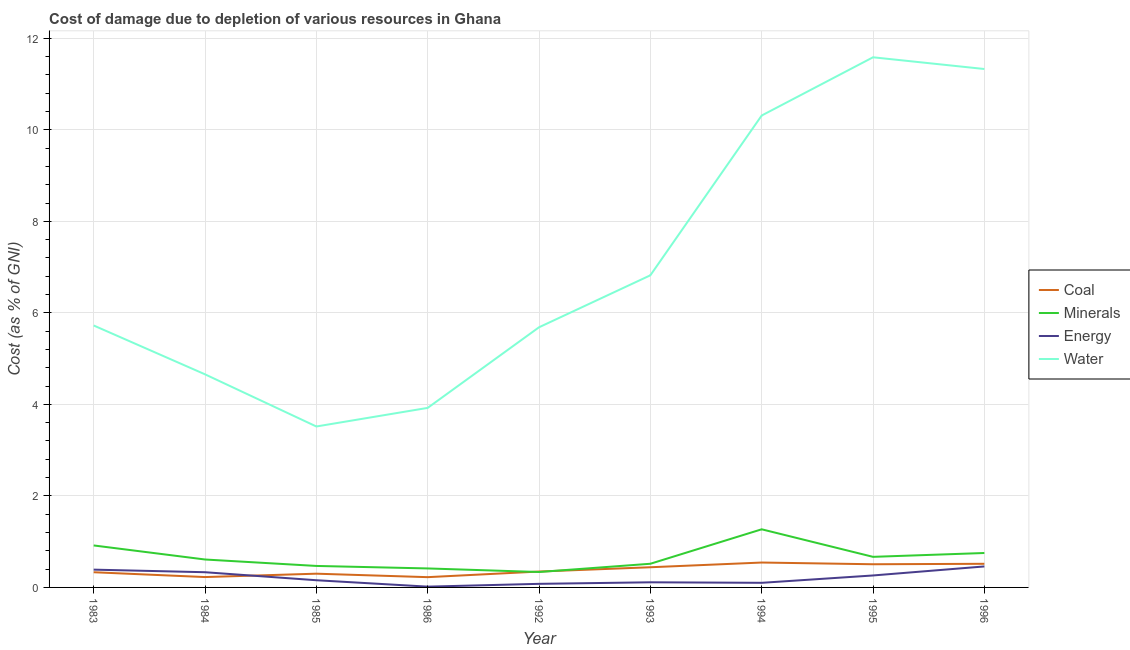Does the line corresponding to cost of damage due to depletion of coal intersect with the line corresponding to cost of damage due to depletion of energy?
Provide a succinct answer. Yes. What is the cost of damage due to depletion of coal in 1995?
Provide a succinct answer. 0.51. Across all years, what is the maximum cost of damage due to depletion of coal?
Keep it short and to the point. 0.54. Across all years, what is the minimum cost of damage due to depletion of energy?
Offer a terse response. 0.02. In which year was the cost of damage due to depletion of water maximum?
Make the answer very short. 1995. In which year was the cost of damage due to depletion of water minimum?
Offer a very short reply. 1985. What is the total cost of damage due to depletion of water in the graph?
Provide a short and direct response. 63.55. What is the difference between the cost of damage due to depletion of coal in 1986 and that in 1996?
Keep it short and to the point. -0.29. What is the difference between the cost of damage due to depletion of energy in 1985 and the cost of damage due to depletion of coal in 1983?
Provide a short and direct response. -0.18. What is the average cost of damage due to depletion of water per year?
Give a very brief answer. 7.06. In the year 1983, what is the difference between the cost of damage due to depletion of water and cost of damage due to depletion of energy?
Your response must be concise. 5.34. In how many years, is the cost of damage due to depletion of water greater than 10.8 %?
Your answer should be very brief. 2. What is the ratio of the cost of damage due to depletion of coal in 1994 to that in 1995?
Ensure brevity in your answer.  1.07. Is the difference between the cost of damage due to depletion of coal in 1992 and 1995 greater than the difference between the cost of damage due to depletion of water in 1992 and 1995?
Make the answer very short. Yes. What is the difference between the highest and the second highest cost of damage due to depletion of minerals?
Keep it short and to the point. 0.35. What is the difference between the highest and the lowest cost of damage due to depletion of coal?
Ensure brevity in your answer.  0.32. Is it the case that in every year, the sum of the cost of damage due to depletion of minerals and cost of damage due to depletion of water is greater than the sum of cost of damage due to depletion of coal and cost of damage due to depletion of energy?
Keep it short and to the point. No. Is it the case that in every year, the sum of the cost of damage due to depletion of coal and cost of damage due to depletion of minerals is greater than the cost of damage due to depletion of energy?
Keep it short and to the point. Yes. Is the cost of damage due to depletion of water strictly less than the cost of damage due to depletion of energy over the years?
Provide a succinct answer. No. What is the difference between two consecutive major ticks on the Y-axis?
Provide a succinct answer. 2. Are the values on the major ticks of Y-axis written in scientific E-notation?
Your response must be concise. No. What is the title of the graph?
Provide a short and direct response. Cost of damage due to depletion of various resources in Ghana . Does "Methodology assessment" appear as one of the legend labels in the graph?
Offer a very short reply. No. What is the label or title of the Y-axis?
Provide a short and direct response. Cost (as % of GNI). What is the Cost (as % of GNI) in Coal in 1983?
Keep it short and to the point. 0.33. What is the Cost (as % of GNI) in Minerals in 1983?
Your answer should be very brief. 0.92. What is the Cost (as % of GNI) in Energy in 1983?
Your answer should be compact. 0.39. What is the Cost (as % of GNI) in Water in 1983?
Your answer should be very brief. 5.72. What is the Cost (as % of GNI) in Coal in 1984?
Provide a succinct answer. 0.23. What is the Cost (as % of GNI) in Minerals in 1984?
Your response must be concise. 0.61. What is the Cost (as % of GNI) in Energy in 1984?
Offer a terse response. 0.33. What is the Cost (as % of GNI) in Water in 1984?
Make the answer very short. 4.66. What is the Cost (as % of GNI) in Coal in 1985?
Keep it short and to the point. 0.3. What is the Cost (as % of GNI) of Minerals in 1985?
Provide a short and direct response. 0.47. What is the Cost (as % of GNI) of Energy in 1985?
Give a very brief answer. 0.16. What is the Cost (as % of GNI) of Water in 1985?
Your answer should be compact. 3.52. What is the Cost (as % of GNI) of Coal in 1986?
Provide a succinct answer. 0.22. What is the Cost (as % of GNI) of Minerals in 1986?
Offer a very short reply. 0.41. What is the Cost (as % of GNI) of Energy in 1986?
Your answer should be very brief. 0.02. What is the Cost (as % of GNI) of Water in 1986?
Offer a very short reply. 3.92. What is the Cost (as % of GNI) of Coal in 1992?
Offer a very short reply. 0.35. What is the Cost (as % of GNI) in Minerals in 1992?
Provide a short and direct response. 0.34. What is the Cost (as % of GNI) of Energy in 1992?
Make the answer very short. 0.08. What is the Cost (as % of GNI) of Water in 1992?
Offer a very short reply. 5.68. What is the Cost (as % of GNI) of Coal in 1993?
Make the answer very short. 0.44. What is the Cost (as % of GNI) in Minerals in 1993?
Ensure brevity in your answer.  0.52. What is the Cost (as % of GNI) in Energy in 1993?
Keep it short and to the point. 0.11. What is the Cost (as % of GNI) in Water in 1993?
Your response must be concise. 6.82. What is the Cost (as % of GNI) in Coal in 1994?
Offer a very short reply. 0.54. What is the Cost (as % of GNI) of Minerals in 1994?
Provide a succinct answer. 1.27. What is the Cost (as % of GNI) in Energy in 1994?
Your answer should be compact. 0.1. What is the Cost (as % of GNI) of Water in 1994?
Offer a very short reply. 10.31. What is the Cost (as % of GNI) in Coal in 1995?
Your answer should be compact. 0.51. What is the Cost (as % of GNI) in Minerals in 1995?
Offer a terse response. 0.67. What is the Cost (as % of GNI) of Energy in 1995?
Your answer should be very brief. 0.26. What is the Cost (as % of GNI) of Water in 1995?
Offer a very short reply. 11.58. What is the Cost (as % of GNI) of Coal in 1996?
Provide a short and direct response. 0.52. What is the Cost (as % of GNI) of Minerals in 1996?
Provide a succinct answer. 0.75. What is the Cost (as % of GNI) in Energy in 1996?
Make the answer very short. 0.46. What is the Cost (as % of GNI) of Water in 1996?
Your response must be concise. 11.33. Across all years, what is the maximum Cost (as % of GNI) in Coal?
Your answer should be compact. 0.54. Across all years, what is the maximum Cost (as % of GNI) of Minerals?
Keep it short and to the point. 1.27. Across all years, what is the maximum Cost (as % of GNI) in Energy?
Provide a succinct answer. 0.46. Across all years, what is the maximum Cost (as % of GNI) in Water?
Provide a short and direct response. 11.58. Across all years, what is the minimum Cost (as % of GNI) of Coal?
Your answer should be compact. 0.22. Across all years, what is the minimum Cost (as % of GNI) of Minerals?
Make the answer very short. 0.34. Across all years, what is the minimum Cost (as % of GNI) in Energy?
Provide a short and direct response. 0.02. Across all years, what is the minimum Cost (as % of GNI) of Water?
Give a very brief answer. 3.52. What is the total Cost (as % of GNI) in Coal in the graph?
Your answer should be compact. 3.44. What is the total Cost (as % of GNI) of Minerals in the graph?
Give a very brief answer. 5.96. What is the total Cost (as % of GNI) of Energy in the graph?
Your answer should be very brief. 1.91. What is the total Cost (as % of GNI) in Water in the graph?
Offer a terse response. 63.55. What is the difference between the Cost (as % of GNI) of Coal in 1983 and that in 1984?
Offer a terse response. 0.11. What is the difference between the Cost (as % of GNI) in Minerals in 1983 and that in 1984?
Offer a terse response. 0.31. What is the difference between the Cost (as % of GNI) in Energy in 1983 and that in 1984?
Offer a terse response. 0.06. What is the difference between the Cost (as % of GNI) in Water in 1983 and that in 1984?
Give a very brief answer. 1.07. What is the difference between the Cost (as % of GNI) in Coal in 1983 and that in 1985?
Your answer should be very brief. 0.03. What is the difference between the Cost (as % of GNI) in Minerals in 1983 and that in 1985?
Provide a short and direct response. 0.45. What is the difference between the Cost (as % of GNI) in Energy in 1983 and that in 1985?
Provide a short and direct response. 0.23. What is the difference between the Cost (as % of GNI) in Water in 1983 and that in 1985?
Ensure brevity in your answer.  2.21. What is the difference between the Cost (as % of GNI) in Coal in 1983 and that in 1986?
Your response must be concise. 0.11. What is the difference between the Cost (as % of GNI) of Minerals in 1983 and that in 1986?
Keep it short and to the point. 0.5. What is the difference between the Cost (as % of GNI) of Energy in 1983 and that in 1986?
Your answer should be compact. 0.37. What is the difference between the Cost (as % of GNI) in Water in 1983 and that in 1986?
Provide a short and direct response. 1.8. What is the difference between the Cost (as % of GNI) of Coal in 1983 and that in 1992?
Your answer should be compact. -0.01. What is the difference between the Cost (as % of GNI) in Minerals in 1983 and that in 1992?
Provide a succinct answer. 0.58. What is the difference between the Cost (as % of GNI) in Energy in 1983 and that in 1992?
Offer a very short reply. 0.31. What is the difference between the Cost (as % of GNI) in Water in 1983 and that in 1992?
Keep it short and to the point. 0.04. What is the difference between the Cost (as % of GNI) of Coal in 1983 and that in 1993?
Give a very brief answer. -0.11. What is the difference between the Cost (as % of GNI) of Minerals in 1983 and that in 1993?
Give a very brief answer. 0.4. What is the difference between the Cost (as % of GNI) in Energy in 1983 and that in 1993?
Offer a terse response. 0.28. What is the difference between the Cost (as % of GNI) of Water in 1983 and that in 1993?
Offer a terse response. -1.1. What is the difference between the Cost (as % of GNI) of Coal in 1983 and that in 1994?
Your answer should be very brief. -0.21. What is the difference between the Cost (as % of GNI) in Minerals in 1983 and that in 1994?
Offer a terse response. -0.35. What is the difference between the Cost (as % of GNI) in Energy in 1983 and that in 1994?
Offer a terse response. 0.29. What is the difference between the Cost (as % of GNI) in Water in 1983 and that in 1994?
Ensure brevity in your answer.  -4.59. What is the difference between the Cost (as % of GNI) of Coal in 1983 and that in 1995?
Offer a very short reply. -0.17. What is the difference between the Cost (as % of GNI) of Minerals in 1983 and that in 1995?
Offer a very short reply. 0.25. What is the difference between the Cost (as % of GNI) of Energy in 1983 and that in 1995?
Make the answer very short. 0.13. What is the difference between the Cost (as % of GNI) of Water in 1983 and that in 1995?
Give a very brief answer. -5.86. What is the difference between the Cost (as % of GNI) in Coal in 1983 and that in 1996?
Make the answer very short. -0.18. What is the difference between the Cost (as % of GNI) of Minerals in 1983 and that in 1996?
Give a very brief answer. 0.17. What is the difference between the Cost (as % of GNI) of Energy in 1983 and that in 1996?
Offer a terse response. -0.07. What is the difference between the Cost (as % of GNI) of Water in 1983 and that in 1996?
Provide a short and direct response. -5.6. What is the difference between the Cost (as % of GNI) in Coal in 1984 and that in 1985?
Give a very brief answer. -0.07. What is the difference between the Cost (as % of GNI) in Minerals in 1984 and that in 1985?
Keep it short and to the point. 0.14. What is the difference between the Cost (as % of GNI) of Energy in 1984 and that in 1985?
Make the answer very short. 0.18. What is the difference between the Cost (as % of GNI) of Water in 1984 and that in 1985?
Make the answer very short. 1.14. What is the difference between the Cost (as % of GNI) of Coal in 1984 and that in 1986?
Your answer should be compact. 0. What is the difference between the Cost (as % of GNI) of Minerals in 1984 and that in 1986?
Provide a succinct answer. 0.2. What is the difference between the Cost (as % of GNI) of Energy in 1984 and that in 1986?
Your answer should be very brief. 0.32. What is the difference between the Cost (as % of GNI) of Water in 1984 and that in 1986?
Give a very brief answer. 0.73. What is the difference between the Cost (as % of GNI) of Coal in 1984 and that in 1992?
Offer a terse response. -0.12. What is the difference between the Cost (as % of GNI) in Minerals in 1984 and that in 1992?
Make the answer very short. 0.27. What is the difference between the Cost (as % of GNI) of Energy in 1984 and that in 1992?
Your answer should be very brief. 0.25. What is the difference between the Cost (as % of GNI) of Water in 1984 and that in 1992?
Your answer should be very brief. -1.03. What is the difference between the Cost (as % of GNI) of Coal in 1984 and that in 1993?
Your response must be concise. -0.21. What is the difference between the Cost (as % of GNI) in Minerals in 1984 and that in 1993?
Ensure brevity in your answer.  0.09. What is the difference between the Cost (as % of GNI) of Energy in 1984 and that in 1993?
Provide a succinct answer. 0.22. What is the difference between the Cost (as % of GNI) of Water in 1984 and that in 1993?
Provide a short and direct response. -2.16. What is the difference between the Cost (as % of GNI) in Coal in 1984 and that in 1994?
Offer a terse response. -0.32. What is the difference between the Cost (as % of GNI) in Minerals in 1984 and that in 1994?
Your answer should be very brief. -0.66. What is the difference between the Cost (as % of GNI) in Energy in 1984 and that in 1994?
Offer a very short reply. 0.23. What is the difference between the Cost (as % of GNI) of Water in 1984 and that in 1994?
Offer a terse response. -5.66. What is the difference between the Cost (as % of GNI) in Coal in 1984 and that in 1995?
Your answer should be very brief. -0.28. What is the difference between the Cost (as % of GNI) in Minerals in 1984 and that in 1995?
Keep it short and to the point. -0.06. What is the difference between the Cost (as % of GNI) in Energy in 1984 and that in 1995?
Offer a terse response. 0.07. What is the difference between the Cost (as % of GNI) of Water in 1984 and that in 1995?
Your response must be concise. -6.93. What is the difference between the Cost (as % of GNI) of Coal in 1984 and that in 1996?
Give a very brief answer. -0.29. What is the difference between the Cost (as % of GNI) of Minerals in 1984 and that in 1996?
Offer a terse response. -0.14. What is the difference between the Cost (as % of GNI) of Energy in 1984 and that in 1996?
Offer a very short reply. -0.13. What is the difference between the Cost (as % of GNI) in Water in 1984 and that in 1996?
Provide a short and direct response. -6.67. What is the difference between the Cost (as % of GNI) in Coal in 1985 and that in 1986?
Ensure brevity in your answer.  0.08. What is the difference between the Cost (as % of GNI) of Minerals in 1985 and that in 1986?
Your response must be concise. 0.05. What is the difference between the Cost (as % of GNI) of Energy in 1985 and that in 1986?
Give a very brief answer. 0.14. What is the difference between the Cost (as % of GNI) in Water in 1985 and that in 1986?
Provide a short and direct response. -0.41. What is the difference between the Cost (as % of GNI) in Coal in 1985 and that in 1992?
Give a very brief answer. -0.05. What is the difference between the Cost (as % of GNI) in Minerals in 1985 and that in 1992?
Ensure brevity in your answer.  0.13. What is the difference between the Cost (as % of GNI) in Energy in 1985 and that in 1992?
Provide a succinct answer. 0.08. What is the difference between the Cost (as % of GNI) in Water in 1985 and that in 1992?
Offer a terse response. -2.17. What is the difference between the Cost (as % of GNI) in Coal in 1985 and that in 1993?
Give a very brief answer. -0.14. What is the difference between the Cost (as % of GNI) in Minerals in 1985 and that in 1993?
Give a very brief answer. -0.05. What is the difference between the Cost (as % of GNI) in Energy in 1985 and that in 1993?
Your response must be concise. 0.05. What is the difference between the Cost (as % of GNI) of Water in 1985 and that in 1993?
Offer a terse response. -3.3. What is the difference between the Cost (as % of GNI) in Coal in 1985 and that in 1994?
Make the answer very short. -0.24. What is the difference between the Cost (as % of GNI) in Minerals in 1985 and that in 1994?
Your answer should be very brief. -0.8. What is the difference between the Cost (as % of GNI) of Energy in 1985 and that in 1994?
Offer a very short reply. 0.06. What is the difference between the Cost (as % of GNI) in Water in 1985 and that in 1994?
Offer a terse response. -6.8. What is the difference between the Cost (as % of GNI) in Coal in 1985 and that in 1995?
Keep it short and to the point. -0.21. What is the difference between the Cost (as % of GNI) in Minerals in 1985 and that in 1995?
Ensure brevity in your answer.  -0.2. What is the difference between the Cost (as % of GNI) in Energy in 1985 and that in 1995?
Make the answer very short. -0.1. What is the difference between the Cost (as % of GNI) in Water in 1985 and that in 1995?
Keep it short and to the point. -8.07. What is the difference between the Cost (as % of GNI) in Coal in 1985 and that in 1996?
Give a very brief answer. -0.22. What is the difference between the Cost (as % of GNI) of Minerals in 1985 and that in 1996?
Your answer should be very brief. -0.28. What is the difference between the Cost (as % of GNI) in Energy in 1985 and that in 1996?
Ensure brevity in your answer.  -0.3. What is the difference between the Cost (as % of GNI) of Water in 1985 and that in 1996?
Ensure brevity in your answer.  -7.81. What is the difference between the Cost (as % of GNI) of Coal in 1986 and that in 1992?
Offer a terse response. -0.12. What is the difference between the Cost (as % of GNI) in Minerals in 1986 and that in 1992?
Provide a succinct answer. 0.08. What is the difference between the Cost (as % of GNI) of Energy in 1986 and that in 1992?
Give a very brief answer. -0.06. What is the difference between the Cost (as % of GNI) in Water in 1986 and that in 1992?
Offer a very short reply. -1.76. What is the difference between the Cost (as % of GNI) of Coal in 1986 and that in 1993?
Your answer should be compact. -0.22. What is the difference between the Cost (as % of GNI) in Minerals in 1986 and that in 1993?
Provide a succinct answer. -0.1. What is the difference between the Cost (as % of GNI) of Energy in 1986 and that in 1993?
Keep it short and to the point. -0.09. What is the difference between the Cost (as % of GNI) of Water in 1986 and that in 1993?
Offer a very short reply. -2.9. What is the difference between the Cost (as % of GNI) in Coal in 1986 and that in 1994?
Your response must be concise. -0.32. What is the difference between the Cost (as % of GNI) in Minerals in 1986 and that in 1994?
Your response must be concise. -0.86. What is the difference between the Cost (as % of GNI) in Energy in 1986 and that in 1994?
Your answer should be compact. -0.08. What is the difference between the Cost (as % of GNI) of Water in 1986 and that in 1994?
Offer a very short reply. -6.39. What is the difference between the Cost (as % of GNI) of Coal in 1986 and that in 1995?
Give a very brief answer. -0.28. What is the difference between the Cost (as % of GNI) in Minerals in 1986 and that in 1995?
Your response must be concise. -0.25. What is the difference between the Cost (as % of GNI) in Energy in 1986 and that in 1995?
Make the answer very short. -0.24. What is the difference between the Cost (as % of GNI) of Water in 1986 and that in 1995?
Provide a short and direct response. -7.66. What is the difference between the Cost (as % of GNI) in Coal in 1986 and that in 1996?
Provide a short and direct response. -0.29. What is the difference between the Cost (as % of GNI) of Minerals in 1986 and that in 1996?
Your response must be concise. -0.34. What is the difference between the Cost (as % of GNI) of Energy in 1986 and that in 1996?
Offer a very short reply. -0.44. What is the difference between the Cost (as % of GNI) of Water in 1986 and that in 1996?
Your answer should be very brief. -7.41. What is the difference between the Cost (as % of GNI) of Coal in 1992 and that in 1993?
Provide a short and direct response. -0.09. What is the difference between the Cost (as % of GNI) of Minerals in 1992 and that in 1993?
Provide a succinct answer. -0.18. What is the difference between the Cost (as % of GNI) of Energy in 1992 and that in 1993?
Your answer should be compact. -0.03. What is the difference between the Cost (as % of GNI) in Water in 1992 and that in 1993?
Provide a short and direct response. -1.14. What is the difference between the Cost (as % of GNI) in Coal in 1992 and that in 1994?
Ensure brevity in your answer.  -0.2. What is the difference between the Cost (as % of GNI) in Minerals in 1992 and that in 1994?
Your answer should be very brief. -0.93. What is the difference between the Cost (as % of GNI) in Energy in 1992 and that in 1994?
Provide a short and direct response. -0.02. What is the difference between the Cost (as % of GNI) of Water in 1992 and that in 1994?
Offer a terse response. -4.63. What is the difference between the Cost (as % of GNI) of Coal in 1992 and that in 1995?
Keep it short and to the point. -0.16. What is the difference between the Cost (as % of GNI) of Minerals in 1992 and that in 1995?
Provide a succinct answer. -0.33. What is the difference between the Cost (as % of GNI) of Energy in 1992 and that in 1995?
Your answer should be compact. -0.18. What is the difference between the Cost (as % of GNI) in Water in 1992 and that in 1995?
Offer a very short reply. -5.9. What is the difference between the Cost (as % of GNI) of Coal in 1992 and that in 1996?
Offer a very short reply. -0.17. What is the difference between the Cost (as % of GNI) of Minerals in 1992 and that in 1996?
Provide a succinct answer. -0.42. What is the difference between the Cost (as % of GNI) of Energy in 1992 and that in 1996?
Your answer should be very brief. -0.38. What is the difference between the Cost (as % of GNI) of Water in 1992 and that in 1996?
Offer a terse response. -5.64. What is the difference between the Cost (as % of GNI) of Coal in 1993 and that in 1994?
Your answer should be compact. -0.1. What is the difference between the Cost (as % of GNI) of Minerals in 1993 and that in 1994?
Your response must be concise. -0.75. What is the difference between the Cost (as % of GNI) of Energy in 1993 and that in 1994?
Your answer should be very brief. 0.01. What is the difference between the Cost (as % of GNI) of Water in 1993 and that in 1994?
Your response must be concise. -3.49. What is the difference between the Cost (as % of GNI) of Coal in 1993 and that in 1995?
Keep it short and to the point. -0.07. What is the difference between the Cost (as % of GNI) in Minerals in 1993 and that in 1995?
Give a very brief answer. -0.15. What is the difference between the Cost (as % of GNI) in Energy in 1993 and that in 1995?
Keep it short and to the point. -0.15. What is the difference between the Cost (as % of GNI) in Water in 1993 and that in 1995?
Keep it short and to the point. -4.76. What is the difference between the Cost (as % of GNI) of Coal in 1993 and that in 1996?
Your answer should be compact. -0.08. What is the difference between the Cost (as % of GNI) in Minerals in 1993 and that in 1996?
Keep it short and to the point. -0.24. What is the difference between the Cost (as % of GNI) of Energy in 1993 and that in 1996?
Your answer should be compact. -0.35. What is the difference between the Cost (as % of GNI) of Water in 1993 and that in 1996?
Provide a succinct answer. -4.51. What is the difference between the Cost (as % of GNI) of Coal in 1994 and that in 1995?
Offer a very short reply. 0.04. What is the difference between the Cost (as % of GNI) in Minerals in 1994 and that in 1995?
Provide a succinct answer. 0.6. What is the difference between the Cost (as % of GNI) in Energy in 1994 and that in 1995?
Provide a short and direct response. -0.16. What is the difference between the Cost (as % of GNI) of Water in 1994 and that in 1995?
Provide a short and direct response. -1.27. What is the difference between the Cost (as % of GNI) of Coal in 1994 and that in 1996?
Offer a terse response. 0.03. What is the difference between the Cost (as % of GNI) in Minerals in 1994 and that in 1996?
Your response must be concise. 0.52. What is the difference between the Cost (as % of GNI) in Energy in 1994 and that in 1996?
Make the answer very short. -0.36. What is the difference between the Cost (as % of GNI) in Water in 1994 and that in 1996?
Your answer should be compact. -1.02. What is the difference between the Cost (as % of GNI) of Coal in 1995 and that in 1996?
Your answer should be compact. -0.01. What is the difference between the Cost (as % of GNI) of Minerals in 1995 and that in 1996?
Your response must be concise. -0.08. What is the difference between the Cost (as % of GNI) in Energy in 1995 and that in 1996?
Offer a terse response. -0.2. What is the difference between the Cost (as % of GNI) of Water in 1995 and that in 1996?
Your response must be concise. 0.26. What is the difference between the Cost (as % of GNI) of Coal in 1983 and the Cost (as % of GNI) of Minerals in 1984?
Ensure brevity in your answer.  -0.28. What is the difference between the Cost (as % of GNI) of Coal in 1983 and the Cost (as % of GNI) of Energy in 1984?
Offer a very short reply. -0. What is the difference between the Cost (as % of GNI) in Coal in 1983 and the Cost (as % of GNI) in Water in 1984?
Your answer should be very brief. -4.32. What is the difference between the Cost (as % of GNI) of Minerals in 1983 and the Cost (as % of GNI) of Energy in 1984?
Provide a succinct answer. 0.58. What is the difference between the Cost (as % of GNI) of Minerals in 1983 and the Cost (as % of GNI) of Water in 1984?
Make the answer very short. -3.74. What is the difference between the Cost (as % of GNI) of Energy in 1983 and the Cost (as % of GNI) of Water in 1984?
Provide a short and direct response. -4.27. What is the difference between the Cost (as % of GNI) of Coal in 1983 and the Cost (as % of GNI) of Minerals in 1985?
Your answer should be very brief. -0.14. What is the difference between the Cost (as % of GNI) of Coal in 1983 and the Cost (as % of GNI) of Energy in 1985?
Provide a short and direct response. 0.17. What is the difference between the Cost (as % of GNI) of Coal in 1983 and the Cost (as % of GNI) of Water in 1985?
Your answer should be compact. -3.18. What is the difference between the Cost (as % of GNI) of Minerals in 1983 and the Cost (as % of GNI) of Energy in 1985?
Give a very brief answer. 0.76. What is the difference between the Cost (as % of GNI) of Minerals in 1983 and the Cost (as % of GNI) of Water in 1985?
Your answer should be compact. -2.6. What is the difference between the Cost (as % of GNI) in Energy in 1983 and the Cost (as % of GNI) in Water in 1985?
Provide a succinct answer. -3.13. What is the difference between the Cost (as % of GNI) in Coal in 1983 and the Cost (as % of GNI) in Minerals in 1986?
Your answer should be compact. -0.08. What is the difference between the Cost (as % of GNI) in Coal in 1983 and the Cost (as % of GNI) in Energy in 1986?
Make the answer very short. 0.31. What is the difference between the Cost (as % of GNI) of Coal in 1983 and the Cost (as % of GNI) of Water in 1986?
Keep it short and to the point. -3.59. What is the difference between the Cost (as % of GNI) in Minerals in 1983 and the Cost (as % of GNI) in Energy in 1986?
Provide a short and direct response. 0.9. What is the difference between the Cost (as % of GNI) in Minerals in 1983 and the Cost (as % of GNI) in Water in 1986?
Your answer should be compact. -3.01. What is the difference between the Cost (as % of GNI) of Energy in 1983 and the Cost (as % of GNI) of Water in 1986?
Your answer should be very brief. -3.53. What is the difference between the Cost (as % of GNI) in Coal in 1983 and the Cost (as % of GNI) in Minerals in 1992?
Ensure brevity in your answer.  -0.01. What is the difference between the Cost (as % of GNI) in Coal in 1983 and the Cost (as % of GNI) in Energy in 1992?
Keep it short and to the point. 0.25. What is the difference between the Cost (as % of GNI) in Coal in 1983 and the Cost (as % of GNI) in Water in 1992?
Give a very brief answer. -5.35. What is the difference between the Cost (as % of GNI) in Minerals in 1983 and the Cost (as % of GNI) in Energy in 1992?
Your response must be concise. 0.84. What is the difference between the Cost (as % of GNI) in Minerals in 1983 and the Cost (as % of GNI) in Water in 1992?
Provide a short and direct response. -4.77. What is the difference between the Cost (as % of GNI) of Energy in 1983 and the Cost (as % of GNI) of Water in 1992?
Provide a short and direct response. -5.3. What is the difference between the Cost (as % of GNI) in Coal in 1983 and the Cost (as % of GNI) in Minerals in 1993?
Provide a succinct answer. -0.19. What is the difference between the Cost (as % of GNI) of Coal in 1983 and the Cost (as % of GNI) of Energy in 1993?
Ensure brevity in your answer.  0.22. What is the difference between the Cost (as % of GNI) of Coal in 1983 and the Cost (as % of GNI) of Water in 1993?
Provide a short and direct response. -6.49. What is the difference between the Cost (as % of GNI) in Minerals in 1983 and the Cost (as % of GNI) in Energy in 1993?
Ensure brevity in your answer.  0.81. What is the difference between the Cost (as % of GNI) of Minerals in 1983 and the Cost (as % of GNI) of Water in 1993?
Offer a very short reply. -5.9. What is the difference between the Cost (as % of GNI) of Energy in 1983 and the Cost (as % of GNI) of Water in 1993?
Give a very brief answer. -6.43. What is the difference between the Cost (as % of GNI) in Coal in 1983 and the Cost (as % of GNI) in Minerals in 1994?
Ensure brevity in your answer.  -0.94. What is the difference between the Cost (as % of GNI) in Coal in 1983 and the Cost (as % of GNI) in Energy in 1994?
Give a very brief answer. 0.23. What is the difference between the Cost (as % of GNI) in Coal in 1983 and the Cost (as % of GNI) in Water in 1994?
Give a very brief answer. -9.98. What is the difference between the Cost (as % of GNI) in Minerals in 1983 and the Cost (as % of GNI) in Energy in 1994?
Provide a succinct answer. 0.82. What is the difference between the Cost (as % of GNI) in Minerals in 1983 and the Cost (as % of GNI) in Water in 1994?
Make the answer very short. -9.39. What is the difference between the Cost (as % of GNI) in Energy in 1983 and the Cost (as % of GNI) in Water in 1994?
Provide a short and direct response. -9.92. What is the difference between the Cost (as % of GNI) in Coal in 1983 and the Cost (as % of GNI) in Minerals in 1995?
Make the answer very short. -0.34. What is the difference between the Cost (as % of GNI) in Coal in 1983 and the Cost (as % of GNI) in Energy in 1995?
Offer a very short reply. 0.07. What is the difference between the Cost (as % of GNI) of Coal in 1983 and the Cost (as % of GNI) of Water in 1995?
Provide a short and direct response. -11.25. What is the difference between the Cost (as % of GNI) of Minerals in 1983 and the Cost (as % of GNI) of Energy in 1995?
Give a very brief answer. 0.66. What is the difference between the Cost (as % of GNI) of Minerals in 1983 and the Cost (as % of GNI) of Water in 1995?
Offer a very short reply. -10.67. What is the difference between the Cost (as % of GNI) of Energy in 1983 and the Cost (as % of GNI) of Water in 1995?
Make the answer very short. -11.2. What is the difference between the Cost (as % of GNI) in Coal in 1983 and the Cost (as % of GNI) in Minerals in 1996?
Keep it short and to the point. -0.42. What is the difference between the Cost (as % of GNI) in Coal in 1983 and the Cost (as % of GNI) in Energy in 1996?
Give a very brief answer. -0.13. What is the difference between the Cost (as % of GNI) in Coal in 1983 and the Cost (as % of GNI) in Water in 1996?
Make the answer very short. -11. What is the difference between the Cost (as % of GNI) of Minerals in 1983 and the Cost (as % of GNI) of Energy in 1996?
Your answer should be compact. 0.46. What is the difference between the Cost (as % of GNI) of Minerals in 1983 and the Cost (as % of GNI) of Water in 1996?
Keep it short and to the point. -10.41. What is the difference between the Cost (as % of GNI) of Energy in 1983 and the Cost (as % of GNI) of Water in 1996?
Your answer should be compact. -10.94. What is the difference between the Cost (as % of GNI) of Coal in 1984 and the Cost (as % of GNI) of Minerals in 1985?
Make the answer very short. -0.24. What is the difference between the Cost (as % of GNI) in Coal in 1984 and the Cost (as % of GNI) in Energy in 1985?
Give a very brief answer. 0.07. What is the difference between the Cost (as % of GNI) of Coal in 1984 and the Cost (as % of GNI) of Water in 1985?
Your response must be concise. -3.29. What is the difference between the Cost (as % of GNI) of Minerals in 1984 and the Cost (as % of GNI) of Energy in 1985?
Your response must be concise. 0.45. What is the difference between the Cost (as % of GNI) of Minerals in 1984 and the Cost (as % of GNI) of Water in 1985?
Make the answer very short. -2.91. What is the difference between the Cost (as % of GNI) of Energy in 1984 and the Cost (as % of GNI) of Water in 1985?
Provide a succinct answer. -3.18. What is the difference between the Cost (as % of GNI) of Coal in 1984 and the Cost (as % of GNI) of Minerals in 1986?
Your answer should be very brief. -0.19. What is the difference between the Cost (as % of GNI) of Coal in 1984 and the Cost (as % of GNI) of Energy in 1986?
Your response must be concise. 0.21. What is the difference between the Cost (as % of GNI) in Coal in 1984 and the Cost (as % of GNI) in Water in 1986?
Offer a terse response. -3.7. What is the difference between the Cost (as % of GNI) in Minerals in 1984 and the Cost (as % of GNI) in Energy in 1986?
Your answer should be compact. 0.59. What is the difference between the Cost (as % of GNI) in Minerals in 1984 and the Cost (as % of GNI) in Water in 1986?
Keep it short and to the point. -3.31. What is the difference between the Cost (as % of GNI) in Energy in 1984 and the Cost (as % of GNI) in Water in 1986?
Your answer should be very brief. -3.59. What is the difference between the Cost (as % of GNI) of Coal in 1984 and the Cost (as % of GNI) of Minerals in 1992?
Ensure brevity in your answer.  -0.11. What is the difference between the Cost (as % of GNI) of Coal in 1984 and the Cost (as % of GNI) of Energy in 1992?
Give a very brief answer. 0.15. What is the difference between the Cost (as % of GNI) of Coal in 1984 and the Cost (as % of GNI) of Water in 1992?
Keep it short and to the point. -5.46. What is the difference between the Cost (as % of GNI) of Minerals in 1984 and the Cost (as % of GNI) of Energy in 1992?
Give a very brief answer. 0.53. What is the difference between the Cost (as % of GNI) of Minerals in 1984 and the Cost (as % of GNI) of Water in 1992?
Give a very brief answer. -5.07. What is the difference between the Cost (as % of GNI) in Energy in 1984 and the Cost (as % of GNI) in Water in 1992?
Your answer should be very brief. -5.35. What is the difference between the Cost (as % of GNI) in Coal in 1984 and the Cost (as % of GNI) in Minerals in 1993?
Your answer should be very brief. -0.29. What is the difference between the Cost (as % of GNI) of Coal in 1984 and the Cost (as % of GNI) of Energy in 1993?
Provide a short and direct response. 0.11. What is the difference between the Cost (as % of GNI) of Coal in 1984 and the Cost (as % of GNI) of Water in 1993?
Ensure brevity in your answer.  -6.59. What is the difference between the Cost (as % of GNI) in Minerals in 1984 and the Cost (as % of GNI) in Energy in 1993?
Offer a very short reply. 0.5. What is the difference between the Cost (as % of GNI) of Minerals in 1984 and the Cost (as % of GNI) of Water in 1993?
Provide a short and direct response. -6.21. What is the difference between the Cost (as % of GNI) of Energy in 1984 and the Cost (as % of GNI) of Water in 1993?
Your response must be concise. -6.49. What is the difference between the Cost (as % of GNI) of Coal in 1984 and the Cost (as % of GNI) of Minerals in 1994?
Your response must be concise. -1.04. What is the difference between the Cost (as % of GNI) of Coal in 1984 and the Cost (as % of GNI) of Energy in 1994?
Provide a succinct answer. 0.13. What is the difference between the Cost (as % of GNI) in Coal in 1984 and the Cost (as % of GNI) in Water in 1994?
Offer a very short reply. -10.09. What is the difference between the Cost (as % of GNI) in Minerals in 1984 and the Cost (as % of GNI) in Energy in 1994?
Your answer should be compact. 0.51. What is the difference between the Cost (as % of GNI) of Minerals in 1984 and the Cost (as % of GNI) of Water in 1994?
Give a very brief answer. -9.7. What is the difference between the Cost (as % of GNI) in Energy in 1984 and the Cost (as % of GNI) in Water in 1994?
Keep it short and to the point. -9.98. What is the difference between the Cost (as % of GNI) of Coal in 1984 and the Cost (as % of GNI) of Minerals in 1995?
Your answer should be compact. -0.44. What is the difference between the Cost (as % of GNI) of Coal in 1984 and the Cost (as % of GNI) of Energy in 1995?
Offer a terse response. -0.04. What is the difference between the Cost (as % of GNI) of Coal in 1984 and the Cost (as % of GNI) of Water in 1995?
Give a very brief answer. -11.36. What is the difference between the Cost (as % of GNI) of Minerals in 1984 and the Cost (as % of GNI) of Energy in 1995?
Keep it short and to the point. 0.35. What is the difference between the Cost (as % of GNI) in Minerals in 1984 and the Cost (as % of GNI) in Water in 1995?
Provide a short and direct response. -10.97. What is the difference between the Cost (as % of GNI) of Energy in 1984 and the Cost (as % of GNI) of Water in 1995?
Make the answer very short. -11.25. What is the difference between the Cost (as % of GNI) in Coal in 1984 and the Cost (as % of GNI) in Minerals in 1996?
Provide a succinct answer. -0.53. What is the difference between the Cost (as % of GNI) in Coal in 1984 and the Cost (as % of GNI) in Energy in 1996?
Give a very brief answer. -0.23. What is the difference between the Cost (as % of GNI) of Coal in 1984 and the Cost (as % of GNI) of Water in 1996?
Make the answer very short. -11.1. What is the difference between the Cost (as % of GNI) of Minerals in 1984 and the Cost (as % of GNI) of Energy in 1996?
Provide a short and direct response. 0.15. What is the difference between the Cost (as % of GNI) of Minerals in 1984 and the Cost (as % of GNI) of Water in 1996?
Offer a terse response. -10.72. What is the difference between the Cost (as % of GNI) in Energy in 1984 and the Cost (as % of GNI) in Water in 1996?
Offer a very short reply. -11. What is the difference between the Cost (as % of GNI) of Coal in 1985 and the Cost (as % of GNI) of Minerals in 1986?
Provide a succinct answer. -0.11. What is the difference between the Cost (as % of GNI) in Coal in 1985 and the Cost (as % of GNI) in Energy in 1986?
Provide a succinct answer. 0.28. What is the difference between the Cost (as % of GNI) of Coal in 1985 and the Cost (as % of GNI) of Water in 1986?
Offer a very short reply. -3.62. What is the difference between the Cost (as % of GNI) in Minerals in 1985 and the Cost (as % of GNI) in Energy in 1986?
Offer a terse response. 0.45. What is the difference between the Cost (as % of GNI) of Minerals in 1985 and the Cost (as % of GNI) of Water in 1986?
Offer a very short reply. -3.45. What is the difference between the Cost (as % of GNI) of Energy in 1985 and the Cost (as % of GNI) of Water in 1986?
Make the answer very short. -3.77. What is the difference between the Cost (as % of GNI) of Coal in 1985 and the Cost (as % of GNI) of Minerals in 1992?
Provide a succinct answer. -0.04. What is the difference between the Cost (as % of GNI) of Coal in 1985 and the Cost (as % of GNI) of Energy in 1992?
Your answer should be compact. 0.22. What is the difference between the Cost (as % of GNI) in Coal in 1985 and the Cost (as % of GNI) in Water in 1992?
Provide a short and direct response. -5.38. What is the difference between the Cost (as % of GNI) of Minerals in 1985 and the Cost (as % of GNI) of Energy in 1992?
Offer a very short reply. 0.39. What is the difference between the Cost (as % of GNI) of Minerals in 1985 and the Cost (as % of GNI) of Water in 1992?
Provide a succinct answer. -5.22. What is the difference between the Cost (as % of GNI) in Energy in 1985 and the Cost (as % of GNI) in Water in 1992?
Keep it short and to the point. -5.53. What is the difference between the Cost (as % of GNI) in Coal in 1985 and the Cost (as % of GNI) in Minerals in 1993?
Your response must be concise. -0.22. What is the difference between the Cost (as % of GNI) of Coal in 1985 and the Cost (as % of GNI) of Energy in 1993?
Make the answer very short. 0.19. What is the difference between the Cost (as % of GNI) of Coal in 1985 and the Cost (as % of GNI) of Water in 1993?
Give a very brief answer. -6.52. What is the difference between the Cost (as % of GNI) in Minerals in 1985 and the Cost (as % of GNI) in Energy in 1993?
Keep it short and to the point. 0.36. What is the difference between the Cost (as % of GNI) in Minerals in 1985 and the Cost (as % of GNI) in Water in 1993?
Provide a short and direct response. -6.35. What is the difference between the Cost (as % of GNI) of Energy in 1985 and the Cost (as % of GNI) of Water in 1993?
Provide a succinct answer. -6.66. What is the difference between the Cost (as % of GNI) in Coal in 1985 and the Cost (as % of GNI) in Minerals in 1994?
Ensure brevity in your answer.  -0.97. What is the difference between the Cost (as % of GNI) of Coal in 1985 and the Cost (as % of GNI) of Energy in 1994?
Keep it short and to the point. 0.2. What is the difference between the Cost (as % of GNI) of Coal in 1985 and the Cost (as % of GNI) of Water in 1994?
Give a very brief answer. -10.01. What is the difference between the Cost (as % of GNI) in Minerals in 1985 and the Cost (as % of GNI) in Energy in 1994?
Ensure brevity in your answer.  0.37. What is the difference between the Cost (as % of GNI) of Minerals in 1985 and the Cost (as % of GNI) of Water in 1994?
Provide a succinct answer. -9.84. What is the difference between the Cost (as % of GNI) in Energy in 1985 and the Cost (as % of GNI) in Water in 1994?
Your answer should be very brief. -10.16. What is the difference between the Cost (as % of GNI) of Coal in 1985 and the Cost (as % of GNI) of Minerals in 1995?
Offer a very short reply. -0.37. What is the difference between the Cost (as % of GNI) in Coal in 1985 and the Cost (as % of GNI) in Energy in 1995?
Offer a very short reply. 0.04. What is the difference between the Cost (as % of GNI) in Coal in 1985 and the Cost (as % of GNI) in Water in 1995?
Offer a terse response. -11.28. What is the difference between the Cost (as % of GNI) in Minerals in 1985 and the Cost (as % of GNI) in Energy in 1995?
Provide a succinct answer. 0.21. What is the difference between the Cost (as % of GNI) of Minerals in 1985 and the Cost (as % of GNI) of Water in 1995?
Keep it short and to the point. -11.12. What is the difference between the Cost (as % of GNI) in Energy in 1985 and the Cost (as % of GNI) in Water in 1995?
Give a very brief answer. -11.43. What is the difference between the Cost (as % of GNI) of Coal in 1985 and the Cost (as % of GNI) of Minerals in 1996?
Your answer should be compact. -0.45. What is the difference between the Cost (as % of GNI) of Coal in 1985 and the Cost (as % of GNI) of Energy in 1996?
Provide a short and direct response. -0.16. What is the difference between the Cost (as % of GNI) of Coal in 1985 and the Cost (as % of GNI) of Water in 1996?
Provide a short and direct response. -11.03. What is the difference between the Cost (as % of GNI) in Minerals in 1985 and the Cost (as % of GNI) in Energy in 1996?
Give a very brief answer. 0.01. What is the difference between the Cost (as % of GNI) in Minerals in 1985 and the Cost (as % of GNI) in Water in 1996?
Ensure brevity in your answer.  -10.86. What is the difference between the Cost (as % of GNI) of Energy in 1985 and the Cost (as % of GNI) of Water in 1996?
Ensure brevity in your answer.  -11.17. What is the difference between the Cost (as % of GNI) in Coal in 1986 and the Cost (as % of GNI) in Minerals in 1992?
Give a very brief answer. -0.11. What is the difference between the Cost (as % of GNI) of Coal in 1986 and the Cost (as % of GNI) of Energy in 1992?
Your response must be concise. 0.15. What is the difference between the Cost (as % of GNI) of Coal in 1986 and the Cost (as % of GNI) of Water in 1992?
Make the answer very short. -5.46. What is the difference between the Cost (as % of GNI) of Minerals in 1986 and the Cost (as % of GNI) of Energy in 1992?
Give a very brief answer. 0.34. What is the difference between the Cost (as % of GNI) in Minerals in 1986 and the Cost (as % of GNI) in Water in 1992?
Your answer should be compact. -5.27. What is the difference between the Cost (as % of GNI) of Energy in 1986 and the Cost (as % of GNI) of Water in 1992?
Offer a very short reply. -5.67. What is the difference between the Cost (as % of GNI) in Coal in 1986 and the Cost (as % of GNI) in Minerals in 1993?
Give a very brief answer. -0.29. What is the difference between the Cost (as % of GNI) of Coal in 1986 and the Cost (as % of GNI) of Energy in 1993?
Provide a short and direct response. 0.11. What is the difference between the Cost (as % of GNI) of Coal in 1986 and the Cost (as % of GNI) of Water in 1993?
Make the answer very short. -6.6. What is the difference between the Cost (as % of GNI) of Minerals in 1986 and the Cost (as % of GNI) of Energy in 1993?
Your answer should be very brief. 0.3. What is the difference between the Cost (as % of GNI) in Minerals in 1986 and the Cost (as % of GNI) in Water in 1993?
Your answer should be very brief. -6.41. What is the difference between the Cost (as % of GNI) of Energy in 1986 and the Cost (as % of GNI) of Water in 1993?
Keep it short and to the point. -6.8. What is the difference between the Cost (as % of GNI) of Coal in 1986 and the Cost (as % of GNI) of Minerals in 1994?
Your answer should be compact. -1.05. What is the difference between the Cost (as % of GNI) in Coal in 1986 and the Cost (as % of GNI) in Energy in 1994?
Provide a short and direct response. 0.12. What is the difference between the Cost (as % of GNI) in Coal in 1986 and the Cost (as % of GNI) in Water in 1994?
Your response must be concise. -10.09. What is the difference between the Cost (as % of GNI) in Minerals in 1986 and the Cost (as % of GNI) in Energy in 1994?
Your answer should be very brief. 0.31. What is the difference between the Cost (as % of GNI) in Minerals in 1986 and the Cost (as % of GNI) in Water in 1994?
Keep it short and to the point. -9.9. What is the difference between the Cost (as % of GNI) in Energy in 1986 and the Cost (as % of GNI) in Water in 1994?
Provide a succinct answer. -10.3. What is the difference between the Cost (as % of GNI) of Coal in 1986 and the Cost (as % of GNI) of Minerals in 1995?
Your response must be concise. -0.44. What is the difference between the Cost (as % of GNI) in Coal in 1986 and the Cost (as % of GNI) in Energy in 1995?
Your answer should be very brief. -0.04. What is the difference between the Cost (as % of GNI) in Coal in 1986 and the Cost (as % of GNI) in Water in 1995?
Your answer should be compact. -11.36. What is the difference between the Cost (as % of GNI) of Minerals in 1986 and the Cost (as % of GNI) of Energy in 1995?
Your response must be concise. 0.15. What is the difference between the Cost (as % of GNI) in Minerals in 1986 and the Cost (as % of GNI) in Water in 1995?
Your answer should be very brief. -11.17. What is the difference between the Cost (as % of GNI) of Energy in 1986 and the Cost (as % of GNI) of Water in 1995?
Ensure brevity in your answer.  -11.57. What is the difference between the Cost (as % of GNI) of Coal in 1986 and the Cost (as % of GNI) of Minerals in 1996?
Your answer should be compact. -0.53. What is the difference between the Cost (as % of GNI) in Coal in 1986 and the Cost (as % of GNI) in Energy in 1996?
Keep it short and to the point. -0.23. What is the difference between the Cost (as % of GNI) in Coal in 1986 and the Cost (as % of GNI) in Water in 1996?
Your response must be concise. -11.1. What is the difference between the Cost (as % of GNI) of Minerals in 1986 and the Cost (as % of GNI) of Energy in 1996?
Make the answer very short. -0.04. What is the difference between the Cost (as % of GNI) in Minerals in 1986 and the Cost (as % of GNI) in Water in 1996?
Provide a short and direct response. -10.91. What is the difference between the Cost (as % of GNI) in Energy in 1986 and the Cost (as % of GNI) in Water in 1996?
Ensure brevity in your answer.  -11.31. What is the difference between the Cost (as % of GNI) in Coal in 1992 and the Cost (as % of GNI) in Minerals in 1993?
Provide a succinct answer. -0.17. What is the difference between the Cost (as % of GNI) in Coal in 1992 and the Cost (as % of GNI) in Energy in 1993?
Offer a terse response. 0.24. What is the difference between the Cost (as % of GNI) in Coal in 1992 and the Cost (as % of GNI) in Water in 1993?
Offer a terse response. -6.47. What is the difference between the Cost (as % of GNI) of Minerals in 1992 and the Cost (as % of GNI) of Energy in 1993?
Provide a short and direct response. 0.23. What is the difference between the Cost (as % of GNI) of Minerals in 1992 and the Cost (as % of GNI) of Water in 1993?
Offer a very short reply. -6.48. What is the difference between the Cost (as % of GNI) of Energy in 1992 and the Cost (as % of GNI) of Water in 1993?
Your response must be concise. -6.74. What is the difference between the Cost (as % of GNI) of Coal in 1992 and the Cost (as % of GNI) of Minerals in 1994?
Provide a short and direct response. -0.92. What is the difference between the Cost (as % of GNI) of Coal in 1992 and the Cost (as % of GNI) of Energy in 1994?
Offer a very short reply. 0.25. What is the difference between the Cost (as % of GNI) in Coal in 1992 and the Cost (as % of GNI) in Water in 1994?
Provide a short and direct response. -9.97. What is the difference between the Cost (as % of GNI) in Minerals in 1992 and the Cost (as % of GNI) in Energy in 1994?
Provide a short and direct response. 0.24. What is the difference between the Cost (as % of GNI) of Minerals in 1992 and the Cost (as % of GNI) of Water in 1994?
Give a very brief answer. -9.98. What is the difference between the Cost (as % of GNI) in Energy in 1992 and the Cost (as % of GNI) in Water in 1994?
Give a very brief answer. -10.23. What is the difference between the Cost (as % of GNI) in Coal in 1992 and the Cost (as % of GNI) in Minerals in 1995?
Your answer should be very brief. -0.32. What is the difference between the Cost (as % of GNI) of Coal in 1992 and the Cost (as % of GNI) of Energy in 1995?
Make the answer very short. 0.09. What is the difference between the Cost (as % of GNI) in Coal in 1992 and the Cost (as % of GNI) in Water in 1995?
Give a very brief answer. -11.24. What is the difference between the Cost (as % of GNI) in Minerals in 1992 and the Cost (as % of GNI) in Energy in 1995?
Your response must be concise. 0.08. What is the difference between the Cost (as % of GNI) in Minerals in 1992 and the Cost (as % of GNI) in Water in 1995?
Offer a very short reply. -11.25. What is the difference between the Cost (as % of GNI) in Energy in 1992 and the Cost (as % of GNI) in Water in 1995?
Keep it short and to the point. -11.51. What is the difference between the Cost (as % of GNI) of Coal in 1992 and the Cost (as % of GNI) of Minerals in 1996?
Keep it short and to the point. -0.41. What is the difference between the Cost (as % of GNI) of Coal in 1992 and the Cost (as % of GNI) of Energy in 1996?
Your answer should be compact. -0.11. What is the difference between the Cost (as % of GNI) of Coal in 1992 and the Cost (as % of GNI) of Water in 1996?
Your answer should be very brief. -10.98. What is the difference between the Cost (as % of GNI) of Minerals in 1992 and the Cost (as % of GNI) of Energy in 1996?
Your response must be concise. -0.12. What is the difference between the Cost (as % of GNI) of Minerals in 1992 and the Cost (as % of GNI) of Water in 1996?
Offer a very short reply. -10.99. What is the difference between the Cost (as % of GNI) of Energy in 1992 and the Cost (as % of GNI) of Water in 1996?
Offer a terse response. -11.25. What is the difference between the Cost (as % of GNI) in Coal in 1993 and the Cost (as % of GNI) in Minerals in 1994?
Your response must be concise. -0.83. What is the difference between the Cost (as % of GNI) in Coal in 1993 and the Cost (as % of GNI) in Energy in 1994?
Ensure brevity in your answer.  0.34. What is the difference between the Cost (as % of GNI) of Coal in 1993 and the Cost (as % of GNI) of Water in 1994?
Provide a succinct answer. -9.87. What is the difference between the Cost (as % of GNI) in Minerals in 1993 and the Cost (as % of GNI) in Energy in 1994?
Keep it short and to the point. 0.42. What is the difference between the Cost (as % of GNI) in Minerals in 1993 and the Cost (as % of GNI) in Water in 1994?
Your response must be concise. -9.8. What is the difference between the Cost (as % of GNI) of Energy in 1993 and the Cost (as % of GNI) of Water in 1994?
Your answer should be very brief. -10.2. What is the difference between the Cost (as % of GNI) in Coal in 1993 and the Cost (as % of GNI) in Minerals in 1995?
Offer a very short reply. -0.23. What is the difference between the Cost (as % of GNI) in Coal in 1993 and the Cost (as % of GNI) in Energy in 1995?
Ensure brevity in your answer.  0.18. What is the difference between the Cost (as % of GNI) in Coal in 1993 and the Cost (as % of GNI) in Water in 1995?
Provide a succinct answer. -11.14. What is the difference between the Cost (as % of GNI) of Minerals in 1993 and the Cost (as % of GNI) of Energy in 1995?
Ensure brevity in your answer.  0.26. What is the difference between the Cost (as % of GNI) of Minerals in 1993 and the Cost (as % of GNI) of Water in 1995?
Offer a terse response. -11.07. What is the difference between the Cost (as % of GNI) of Energy in 1993 and the Cost (as % of GNI) of Water in 1995?
Ensure brevity in your answer.  -11.47. What is the difference between the Cost (as % of GNI) in Coal in 1993 and the Cost (as % of GNI) in Minerals in 1996?
Provide a succinct answer. -0.31. What is the difference between the Cost (as % of GNI) of Coal in 1993 and the Cost (as % of GNI) of Energy in 1996?
Provide a short and direct response. -0.02. What is the difference between the Cost (as % of GNI) in Coal in 1993 and the Cost (as % of GNI) in Water in 1996?
Give a very brief answer. -10.89. What is the difference between the Cost (as % of GNI) in Minerals in 1993 and the Cost (as % of GNI) in Energy in 1996?
Give a very brief answer. 0.06. What is the difference between the Cost (as % of GNI) in Minerals in 1993 and the Cost (as % of GNI) in Water in 1996?
Your answer should be very brief. -10.81. What is the difference between the Cost (as % of GNI) of Energy in 1993 and the Cost (as % of GNI) of Water in 1996?
Provide a short and direct response. -11.22. What is the difference between the Cost (as % of GNI) in Coal in 1994 and the Cost (as % of GNI) in Minerals in 1995?
Give a very brief answer. -0.12. What is the difference between the Cost (as % of GNI) in Coal in 1994 and the Cost (as % of GNI) in Energy in 1995?
Keep it short and to the point. 0.28. What is the difference between the Cost (as % of GNI) of Coal in 1994 and the Cost (as % of GNI) of Water in 1995?
Provide a succinct answer. -11.04. What is the difference between the Cost (as % of GNI) in Minerals in 1994 and the Cost (as % of GNI) in Energy in 1995?
Make the answer very short. 1.01. What is the difference between the Cost (as % of GNI) of Minerals in 1994 and the Cost (as % of GNI) of Water in 1995?
Offer a terse response. -10.31. What is the difference between the Cost (as % of GNI) of Energy in 1994 and the Cost (as % of GNI) of Water in 1995?
Keep it short and to the point. -11.48. What is the difference between the Cost (as % of GNI) in Coal in 1994 and the Cost (as % of GNI) in Minerals in 1996?
Offer a terse response. -0.21. What is the difference between the Cost (as % of GNI) of Coal in 1994 and the Cost (as % of GNI) of Energy in 1996?
Provide a short and direct response. 0.09. What is the difference between the Cost (as % of GNI) of Coal in 1994 and the Cost (as % of GNI) of Water in 1996?
Provide a succinct answer. -10.78. What is the difference between the Cost (as % of GNI) in Minerals in 1994 and the Cost (as % of GNI) in Energy in 1996?
Ensure brevity in your answer.  0.81. What is the difference between the Cost (as % of GNI) in Minerals in 1994 and the Cost (as % of GNI) in Water in 1996?
Provide a short and direct response. -10.06. What is the difference between the Cost (as % of GNI) in Energy in 1994 and the Cost (as % of GNI) in Water in 1996?
Make the answer very short. -11.23. What is the difference between the Cost (as % of GNI) of Coal in 1995 and the Cost (as % of GNI) of Minerals in 1996?
Ensure brevity in your answer.  -0.25. What is the difference between the Cost (as % of GNI) of Coal in 1995 and the Cost (as % of GNI) of Energy in 1996?
Your response must be concise. 0.05. What is the difference between the Cost (as % of GNI) of Coal in 1995 and the Cost (as % of GNI) of Water in 1996?
Your response must be concise. -10.82. What is the difference between the Cost (as % of GNI) of Minerals in 1995 and the Cost (as % of GNI) of Energy in 1996?
Offer a very short reply. 0.21. What is the difference between the Cost (as % of GNI) in Minerals in 1995 and the Cost (as % of GNI) in Water in 1996?
Offer a very short reply. -10.66. What is the difference between the Cost (as % of GNI) in Energy in 1995 and the Cost (as % of GNI) in Water in 1996?
Provide a short and direct response. -11.07. What is the average Cost (as % of GNI) in Coal per year?
Offer a terse response. 0.38. What is the average Cost (as % of GNI) in Minerals per year?
Provide a succinct answer. 0.66. What is the average Cost (as % of GNI) in Energy per year?
Offer a very short reply. 0.21. What is the average Cost (as % of GNI) in Water per year?
Your answer should be very brief. 7.06. In the year 1983, what is the difference between the Cost (as % of GNI) of Coal and Cost (as % of GNI) of Minerals?
Provide a short and direct response. -0.59. In the year 1983, what is the difference between the Cost (as % of GNI) of Coal and Cost (as % of GNI) of Energy?
Your answer should be compact. -0.06. In the year 1983, what is the difference between the Cost (as % of GNI) of Coal and Cost (as % of GNI) of Water?
Provide a short and direct response. -5.39. In the year 1983, what is the difference between the Cost (as % of GNI) of Minerals and Cost (as % of GNI) of Energy?
Offer a terse response. 0.53. In the year 1983, what is the difference between the Cost (as % of GNI) in Minerals and Cost (as % of GNI) in Water?
Offer a terse response. -4.81. In the year 1983, what is the difference between the Cost (as % of GNI) in Energy and Cost (as % of GNI) in Water?
Provide a short and direct response. -5.34. In the year 1984, what is the difference between the Cost (as % of GNI) in Coal and Cost (as % of GNI) in Minerals?
Your answer should be compact. -0.38. In the year 1984, what is the difference between the Cost (as % of GNI) of Coal and Cost (as % of GNI) of Energy?
Your answer should be compact. -0.11. In the year 1984, what is the difference between the Cost (as % of GNI) in Coal and Cost (as % of GNI) in Water?
Provide a short and direct response. -4.43. In the year 1984, what is the difference between the Cost (as % of GNI) of Minerals and Cost (as % of GNI) of Energy?
Provide a short and direct response. 0.28. In the year 1984, what is the difference between the Cost (as % of GNI) of Minerals and Cost (as % of GNI) of Water?
Offer a terse response. -4.05. In the year 1984, what is the difference between the Cost (as % of GNI) in Energy and Cost (as % of GNI) in Water?
Keep it short and to the point. -4.32. In the year 1985, what is the difference between the Cost (as % of GNI) in Coal and Cost (as % of GNI) in Minerals?
Make the answer very short. -0.17. In the year 1985, what is the difference between the Cost (as % of GNI) in Coal and Cost (as % of GNI) in Energy?
Your response must be concise. 0.14. In the year 1985, what is the difference between the Cost (as % of GNI) of Coal and Cost (as % of GNI) of Water?
Your answer should be very brief. -3.22. In the year 1985, what is the difference between the Cost (as % of GNI) in Minerals and Cost (as % of GNI) in Energy?
Keep it short and to the point. 0.31. In the year 1985, what is the difference between the Cost (as % of GNI) of Minerals and Cost (as % of GNI) of Water?
Keep it short and to the point. -3.05. In the year 1985, what is the difference between the Cost (as % of GNI) in Energy and Cost (as % of GNI) in Water?
Your answer should be compact. -3.36. In the year 1986, what is the difference between the Cost (as % of GNI) in Coal and Cost (as % of GNI) in Minerals?
Ensure brevity in your answer.  -0.19. In the year 1986, what is the difference between the Cost (as % of GNI) of Coal and Cost (as % of GNI) of Energy?
Make the answer very short. 0.21. In the year 1986, what is the difference between the Cost (as % of GNI) of Coal and Cost (as % of GNI) of Water?
Offer a terse response. -3.7. In the year 1986, what is the difference between the Cost (as % of GNI) in Minerals and Cost (as % of GNI) in Energy?
Your answer should be very brief. 0.4. In the year 1986, what is the difference between the Cost (as % of GNI) of Minerals and Cost (as % of GNI) of Water?
Your answer should be compact. -3.51. In the year 1986, what is the difference between the Cost (as % of GNI) in Energy and Cost (as % of GNI) in Water?
Offer a terse response. -3.91. In the year 1992, what is the difference between the Cost (as % of GNI) in Coal and Cost (as % of GNI) in Minerals?
Give a very brief answer. 0.01. In the year 1992, what is the difference between the Cost (as % of GNI) in Coal and Cost (as % of GNI) in Energy?
Make the answer very short. 0.27. In the year 1992, what is the difference between the Cost (as % of GNI) of Coal and Cost (as % of GNI) of Water?
Ensure brevity in your answer.  -5.34. In the year 1992, what is the difference between the Cost (as % of GNI) of Minerals and Cost (as % of GNI) of Energy?
Ensure brevity in your answer.  0.26. In the year 1992, what is the difference between the Cost (as % of GNI) in Minerals and Cost (as % of GNI) in Water?
Provide a succinct answer. -5.35. In the year 1992, what is the difference between the Cost (as % of GNI) in Energy and Cost (as % of GNI) in Water?
Give a very brief answer. -5.61. In the year 1993, what is the difference between the Cost (as % of GNI) in Coal and Cost (as % of GNI) in Minerals?
Your answer should be very brief. -0.08. In the year 1993, what is the difference between the Cost (as % of GNI) in Coal and Cost (as % of GNI) in Energy?
Your response must be concise. 0.33. In the year 1993, what is the difference between the Cost (as % of GNI) in Coal and Cost (as % of GNI) in Water?
Your answer should be compact. -6.38. In the year 1993, what is the difference between the Cost (as % of GNI) of Minerals and Cost (as % of GNI) of Energy?
Provide a succinct answer. 0.41. In the year 1993, what is the difference between the Cost (as % of GNI) in Minerals and Cost (as % of GNI) in Water?
Ensure brevity in your answer.  -6.3. In the year 1993, what is the difference between the Cost (as % of GNI) in Energy and Cost (as % of GNI) in Water?
Make the answer very short. -6.71. In the year 1994, what is the difference between the Cost (as % of GNI) in Coal and Cost (as % of GNI) in Minerals?
Ensure brevity in your answer.  -0.73. In the year 1994, what is the difference between the Cost (as % of GNI) of Coal and Cost (as % of GNI) of Energy?
Provide a short and direct response. 0.44. In the year 1994, what is the difference between the Cost (as % of GNI) in Coal and Cost (as % of GNI) in Water?
Provide a short and direct response. -9.77. In the year 1994, what is the difference between the Cost (as % of GNI) of Minerals and Cost (as % of GNI) of Energy?
Your response must be concise. 1.17. In the year 1994, what is the difference between the Cost (as % of GNI) of Minerals and Cost (as % of GNI) of Water?
Offer a terse response. -9.04. In the year 1994, what is the difference between the Cost (as % of GNI) in Energy and Cost (as % of GNI) in Water?
Offer a terse response. -10.21. In the year 1995, what is the difference between the Cost (as % of GNI) of Coal and Cost (as % of GNI) of Minerals?
Offer a very short reply. -0.16. In the year 1995, what is the difference between the Cost (as % of GNI) in Coal and Cost (as % of GNI) in Energy?
Ensure brevity in your answer.  0.25. In the year 1995, what is the difference between the Cost (as % of GNI) in Coal and Cost (as % of GNI) in Water?
Your answer should be very brief. -11.08. In the year 1995, what is the difference between the Cost (as % of GNI) of Minerals and Cost (as % of GNI) of Energy?
Provide a succinct answer. 0.41. In the year 1995, what is the difference between the Cost (as % of GNI) in Minerals and Cost (as % of GNI) in Water?
Your response must be concise. -10.92. In the year 1995, what is the difference between the Cost (as % of GNI) in Energy and Cost (as % of GNI) in Water?
Your response must be concise. -11.32. In the year 1996, what is the difference between the Cost (as % of GNI) in Coal and Cost (as % of GNI) in Minerals?
Keep it short and to the point. -0.24. In the year 1996, what is the difference between the Cost (as % of GNI) of Coal and Cost (as % of GNI) of Energy?
Make the answer very short. 0.06. In the year 1996, what is the difference between the Cost (as % of GNI) in Coal and Cost (as % of GNI) in Water?
Provide a short and direct response. -10.81. In the year 1996, what is the difference between the Cost (as % of GNI) in Minerals and Cost (as % of GNI) in Energy?
Make the answer very short. 0.29. In the year 1996, what is the difference between the Cost (as % of GNI) in Minerals and Cost (as % of GNI) in Water?
Offer a terse response. -10.58. In the year 1996, what is the difference between the Cost (as % of GNI) in Energy and Cost (as % of GNI) in Water?
Provide a short and direct response. -10.87. What is the ratio of the Cost (as % of GNI) of Coal in 1983 to that in 1984?
Offer a very short reply. 1.47. What is the ratio of the Cost (as % of GNI) of Minerals in 1983 to that in 1984?
Provide a succinct answer. 1.5. What is the ratio of the Cost (as % of GNI) in Energy in 1983 to that in 1984?
Your answer should be very brief. 1.17. What is the ratio of the Cost (as % of GNI) in Water in 1983 to that in 1984?
Provide a short and direct response. 1.23. What is the ratio of the Cost (as % of GNI) in Coal in 1983 to that in 1985?
Offer a terse response. 1.11. What is the ratio of the Cost (as % of GNI) in Minerals in 1983 to that in 1985?
Offer a terse response. 1.95. What is the ratio of the Cost (as % of GNI) of Energy in 1983 to that in 1985?
Provide a succinct answer. 2.47. What is the ratio of the Cost (as % of GNI) in Water in 1983 to that in 1985?
Ensure brevity in your answer.  1.63. What is the ratio of the Cost (as % of GNI) in Coal in 1983 to that in 1986?
Your answer should be very brief. 1.48. What is the ratio of the Cost (as % of GNI) of Minerals in 1983 to that in 1986?
Provide a short and direct response. 2.21. What is the ratio of the Cost (as % of GNI) in Energy in 1983 to that in 1986?
Provide a succinct answer. 22.61. What is the ratio of the Cost (as % of GNI) in Water in 1983 to that in 1986?
Give a very brief answer. 1.46. What is the ratio of the Cost (as % of GNI) in Minerals in 1983 to that in 1992?
Keep it short and to the point. 2.72. What is the ratio of the Cost (as % of GNI) in Energy in 1983 to that in 1992?
Make the answer very short. 4.97. What is the ratio of the Cost (as % of GNI) in Water in 1983 to that in 1992?
Keep it short and to the point. 1.01. What is the ratio of the Cost (as % of GNI) of Coal in 1983 to that in 1993?
Your response must be concise. 0.75. What is the ratio of the Cost (as % of GNI) in Minerals in 1983 to that in 1993?
Provide a succinct answer. 1.77. What is the ratio of the Cost (as % of GNI) of Energy in 1983 to that in 1993?
Offer a terse response. 3.47. What is the ratio of the Cost (as % of GNI) of Water in 1983 to that in 1993?
Offer a terse response. 0.84. What is the ratio of the Cost (as % of GNI) in Coal in 1983 to that in 1994?
Provide a short and direct response. 0.61. What is the ratio of the Cost (as % of GNI) of Minerals in 1983 to that in 1994?
Give a very brief answer. 0.72. What is the ratio of the Cost (as % of GNI) of Energy in 1983 to that in 1994?
Make the answer very short. 3.86. What is the ratio of the Cost (as % of GNI) in Water in 1983 to that in 1994?
Your answer should be very brief. 0.56. What is the ratio of the Cost (as % of GNI) in Coal in 1983 to that in 1995?
Offer a terse response. 0.66. What is the ratio of the Cost (as % of GNI) of Minerals in 1983 to that in 1995?
Your response must be concise. 1.37. What is the ratio of the Cost (as % of GNI) in Energy in 1983 to that in 1995?
Offer a very short reply. 1.49. What is the ratio of the Cost (as % of GNI) of Water in 1983 to that in 1995?
Ensure brevity in your answer.  0.49. What is the ratio of the Cost (as % of GNI) of Coal in 1983 to that in 1996?
Keep it short and to the point. 0.64. What is the ratio of the Cost (as % of GNI) of Minerals in 1983 to that in 1996?
Your answer should be very brief. 1.22. What is the ratio of the Cost (as % of GNI) of Energy in 1983 to that in 1996?
Offer a very short reply. 0.85. What is the ratio of the Cost (as % of GNI) of Water in 1983 to that in 1996?
Ensure brevity in your answer.  0.51. What is the ratio of the Cost (as % of GNI) in Coal in 1984 to that in 1985?
Provide a succinct answer. 0.75. What is the ratio of the Cost (as % of GNI) of Minerals in 1984 to that in 1985?
Your response must be concise. 1.3. What is the ratio of the Cost (as % of GNI) in Energy in 1984 to that in 1985?
Your answer should be very brief. 2.12. What is the ratio of the Cost (as % of GNI) of Water in 1984 to that in 1985?
Your response must be concise. 1.32. What is the ratio of the Cost (as % of GNI) of Coal in 1984 to that in 1986?
Keep it short and to the point. 1.01. What is the ratio of the Cost (as % of GNI) of Minerals in 1984 to that in 1986?
Ensure brevity in your answer.  1.47. What is the ratio of the Cost (as % of GNI) in Energy in 1984 to that in 1986?
Ensure brevity in your answer.  19.33. What is the ratio of the Cost (as % of GNI) of Water in 1984 to that in 1986?
Your answer should be very brief. 1.19. What is the ratio of the Cost (as % of GNI) of Coal in 1984 to that in 1992?
Provide a succinct answer. 0.65. What is the ratio of the Cost (as % of GNI) in Minerals in 1984 to that in 1992?
Offer a terse response. 1.81. What is the ratio of the Cost (as % of GNI) of Energy in 1984 to that in 1992?
Ensure brevity in your answer.  4.25. What is the ratio of the Cost (as % of GNI) in Water in 1984 to that in 1992?
Provide a succinct answer. 0.82. What is the ratio of the Cost (as % of GNI) in Coal in 1984 to that in 1993?
Provide a short and direct response. 0.51. What is the ratio of the Cost (as % of GNI) of Minerals in 1984 to that in 1993?
Ensure brevity in your answer.  1.18. What is the ratio of the Cost (as % of GNI) of Energy in 1984 to that in 1993?
Give a very brief answer. 2.97. What is the ratio of the Cost (as % of GNI) in Water in 1984 to that in 1993?
Keep it short and to the point. 0.68. What is the ratio of the Cost (as % of GNI) in Coal in 1984 to that in 1994?
Offer a terse response. 0.42. What is the ratio of the Cost (as % of GNI) of Minerals in 1984 to that in 1994?
Your answer should be very brief. 0.48. What is the ratio of the Cost (as % of GNI) in Energy in 1984 to that in 1994?
Your answer should be compact. 3.3. What is the ratio of the Cost (as % of GNI) of Water in 1984 to that in 1994?
Provide a short and direct response. 0.45. What is the ratio of the Cost (as % of GNI) of Coal in 1984 to that in 1995?
Provide a short and direct response. 0.45. What is the ratio of the Cost (as % of GNI) of Minerals in 1984 to that in 1995?
Provide a succinct answer. 0.91. What is the ratio of the Cost (as % of GNI) in Energy in 1984 to that in 1995?
Give a very brief answer. 1.27. What is the ratio of the Cost (as % of GNI) of Water in 1984 to that in 1995?
Ensure brevity in your answer.  0.4. What is the ratio of the Cost (as % of GNI) of Coal in 1984 to that in 1996?
Provide a short and direct response. 0.44. What is the ratio of the Cost (as % of GNI) in Minerals in 1984 to that in 1996?
Offer a terse response. 0.81. What is the ratio of the Cost (as % of GNI) in Energy in 1984 to that in 1996?
Your answer should be compact. 0.72. What is the ratio of the Cost (as % of GNI) in Water in 1984 to that in 1996?
Your response must be concise. 0.41. What is the ratio of the Cost (as % of GNI) in Coal in 1985 to that in 1986?
Keep it short and to the point. 1.34. What is the ratio of the Cost (as % of GNI) in Minerals in 1985 to that in 1986?
Provide a short and direct response. 1.13. What is the ratio of the Cost (as % of GNI) of Energy in 1985 to that in 1986?
Your response must be concise. 9.14. What is the ratio of the Cost (as % of GNI) in Water in 1985 to that in 1986?
Your response must be concise. 0.9. What is the ratio of the Cost (as % of GNI) of Coal in 1985 to that in 1992?
Your answer should be very brief. 0.87. What is the ratio of the Cost (as % of GNI) in Minerals in 1985 to that in 1992?
Ensure brevity in your answer.  1.39. What is the ratio of the Cost (as % of GNI) in Energy in 1985 to that in 1992?
Your answer should be compact. 2.01. What is the ratio of the Cost (as % of GNI) of Water in 1985 to that in 1992?
Ensure brevity in your answer.  0.62. What is the ratio of the Cost (as % of GNI) of Coal in 1985 to that in 1993?
Your answer should be very brief. 0.68. What is the ratio of the Cost (as % of GNI) of Minerals in 1985 to that in 1993?
Offer a very short reply. 0.91. What is the ratio of the Cost (as % of GNI) of Energy in 1985 to that in 1993?
Offer a terse response. 1.4. What is the ratio of the Cost (as % of GNI) in Water in 1985 to that in 1993?
Ensure brevity in your answer.  0.52. What is the ratio of the Cost (as % of GNI) of Coal in 1985 to that in 1994?
Offer a very short reply. 0.55. What is the ratio of the Cost (as % of GNI) in Minerals in 1985 to that in 1994?
Ensure brevity in your answer.  0.37. What is the ratio of the Cost (as % of GNI) of Energy in 1985 to that in 1994?
Keep it short and to the point. 1.56. What is the ratio of the Cost (as % of GNI) in Water in 1985 to that in 1994?
Your response must be concise. 0.34. What is the ratio of the Cost (as % of GNI) in Coal in 1985 to that in 1995?
Keep it short and to the point. 0.59. What is the ratio of the Cost (as % of GNI) of Minerals in 1985 to that in 1995?
Provide a succinct answer. 0.7. What is the ratio of the Cost (as % of GNI) in Energy in 1985 to that in 1995?
Ensure brevity in your answer.  0.6. What is the ratio of the Cost (as % of GNI) in Water in 1985 to that in 1995?
Offer a very short reply. 0.3. What is the ratio of the Cost (as % of GNI) in Coal in 1985 to that in 1996?
Provide a short and direct response. 0.58. What is the ratio of the Cost (as % of GNI) in Minerals in 1985 to that in 1996?
Give a very brief answer. 0.62. What is the ratio of the Cost (as % of GNI) in Energy in 1985 to that in 1996?
Offer a terse response. 0.34. What is the ratio of the Cost (as % of GNI) of Water in 1985 to that in 1996?
Ensure brevity in your answer.  0.31. What is the ratio of the Cost (as % of GNI) of Coal in 1986 to that in 1992?
Provide a succinct answer. 0.65. What is the ratio of the Cost (as % of GNI) of Minerals in 1986 to that in 1992?
Your answer should be very brief. 1.23. What is the ratio of the Cost (as % of GNI) in Energy in 1986 to that in 1992?
Provide a short and direct response. 0.22. What is the ratio of the Cost (as % of GNI) in Water in 1986 to that in 1992?
Provide a succinct answer. 0.69. What is the ratio of the Cost (as % of GNI) of Coal in 1986 to that in 1993?
Make the answer very short. 0.51. What is the ratio of the Cost (as % of GNI) of Minerals in 1986 to that in 1993?
Give a very brief answer. 0.8. What is the ratio of the Cost (as % of GNI) of Energy in 1986 to that in 1993?
Provide a short and direct response. 0.15. What is the ratio of the Cost (as % of GNI) in Water in 1986 to that in 1993?
Offer a very short reply. 0.58. What is the ratio of the Cost (as % of GNI) of Coal in 1986 to that in 1994?
Provide a succinct answer. 0.41. What is the ratio of the Cost (as % of GNI) in Minerals in 1986 to that in 1994?
Offer a terse response. 0.33. What is the ratio of the Cost (as % of GNI) in Energy in 1986 to that in 1994?
Keep it short and to the point. 0.17. What is the ratio of the Cost (as % of GNI) of Water in 1986 to that in 1994?
Give a very brief answer. 0.38. What is the ratio of the Cost (as % of GNI) in Coal in 1986 to that in 1995?
Your answer should be compact. 0.44. What is the ratio of the Cost (as % of GNI) in Minerals in 1986 to that in 1995?
Give a very brief answer. 0.62. What is the ratio of the Cost (as % of GNI) in Energy in 1986 to that in 1995?
Your answer should be compact. 0.07. What is the ratio of the Cost (as % of GNI) in Water in 1986 to that in 1995?
Keep it short and to the point. 0.34. What is the ratio of the Cost (as % of GNI) in Coal in 1986 to that in 1996?
Offer a terse response. 0.43. What is the ratio of the Cost (as % of GNI) in Minerals in 1986 to that in 1996?
Ensure brevity in your answer.  0.55. What is the ratio of the Cost (as % of GNI) of Energy in 1986 to that in 1996?
Ensure brevity in your answer.  0.04. What is the ratio of the Cost (as % of GNI) in Water in 1986 to that in 1996?
Your answer should be compact. 0.35. What is the ratio of the Cost (as % of GNI) in Coal in 1992 to that in 1993?
Keep it short and to the point. 0.79. What is the ratio of the Cost (as % of GNI) in Minerals in 1992 to that in 1993?
Offer a very short reply. 0.65. What is the ratio of the Cost (as % of GNI) in Energy in 1992 to that in 1993?
Keep it short and to the point. 0.7. What is the ratio of the Cost (as % of GNI) of Water in 1992 to that in 1993?
Give a very brief answer. 0.83. What is the ratio of the Cost (as % of GNI) of Coal in 1992 to that in 1994?
Your answer should be compact. 0.64. What is the ratio of the Cost (as % of GNI) in Minerals in 1992 to that in 1994?
Your response must be concise. 0.27. What is the ratio of the Cost (as % of GNI) in Energy in 1992 to that in 1994?
Your answer should be very brief. 0.78. What is the ratio of the Cost (as % of GNI) of Water in 1992 to that in 1994?
Give a very brief answer. 0.55. What is the ratio of the Cost (as % of GNI) of Coal in 1992 to that in 1995?
Give a very brief answer. 0.69. What is the ratio of the Cost (as % of GNI) in Minerals in 1992 to that in 1995?
Offer a terse response. 0.5. What is the ratio of the Cost (as % of GNI) in Energy in 1992 to that in 1995?
Offer a terse response. 0.3. What is the ratio of the Cost (as % of GNI) in Water in 1992 to that in 1995?
Give a very brief answer. 0.49. What is the ratio of the Cost (as % of GNI) in Coal in 1992 to that in 1996?
Your answer should be very brief. 0.67. What is the ratio of the Cost (as % of GNI) of Minerals in 1992 to that in 1996?
Your answer should be compact. 0.45. What is the ratio of the Cost (as % of GNI) of Energy in 1992 to that in 1996?
Your response must be concise. 0.17. What is the ratio of the Cost (as % of GNI) in Water in 1992 to that in 1996?
Provide a succinct answer. 0.5. What is the ratio of the Cost (as % of GNI) of Coal in 1993 to that in 1994?
Make the answer very short. 0.81. What is the ratio of the Cost (as % of GNI) of Minerals in 1993 to that in 1994?
Your response must be concise. 0.41. What is the ratio of the Cost (as % of GNI) of Energy in 1993 to that in 1994?
Offer a terse response. 1.11. What is the ratio of the Cost (as % of GNI) of Water in 1993 to that in 1994?
Your answer should be compact. 0.66. What is the ratio of the Cost (as % of GNI) of Coal in 1993 to that in 1995?
Your answer should be very brief. 0.87. What is the ratio of the Cost (as % of GNI) of Minerals in 1993 to that in 1995?
Your answer should be compact. 0.77. What is the ratio of the Cost (as % of GNI) in Energy in 1993 to that in 1995?
Give a very brief answer. 0.43. What is the ratio of the Cost (as % of GNI) of Water in 1993 to that in 1995?
Give a very brief answer. 0.59. What is the ratio of the Cost (as % of GNI) in Coal in 1993 to that in 1996?
Your answer should be compact. 0.85. What is the ratio of the Cost (as % of GNI) in Minerals in 1993 to that in 1996?
Provide a short and direct response. 0.69. What is the ratio of the Cost (as % of GNI) in Energy in 1993 to that in 1996?
Ensure brevity in your answer.  0.24. What is the ratio of the Cost (as % of GNI) in Water in 1993 to that in 1996?
Make the answer very short. 0.6. What is the ratio of the Cost (as % of GNI) in Coal in 1994 to that in 1995?
Make the answer very short. 1.07. What is the ratio of the Cost (as % of GNI) in Minerals in 1994 to that in 1995?
Ensure brevity in your answer.  1.9. What is the ratio of the Cost (as % of GNI) of Energy in 1994 to that in 1995?
Ensure brevity in your answer.  0.39. What is the ratio of the Cost (as % of GNI) in Water in 1994 to that in 1995?
Provide a short and direct response. 0.89. What is the ratio of the Cost (as % of GNI) in Coal in 1994 to that in 1996?
Your response must be concise. 1.05. What is the ratio of the Cost (as % of GNI) in Minerals in 1994 to that in 1996?
Your response must be concise. 1.69. What is the ratio of the Cost (as % of GNI) in Energy in 1994 to that in 1996?
Ensure brevity in your answer.  0.22. What is the ratio of the Cost (as % of GNI) in Water in 1994 to that in 1996?
Give a very brief answer. 0.91. What is the ratio of the Cost (as % of GNI) of Coal in 1995 to that in 1996?
Offer a terse response. 0.98. What is the ratio of the Cost (as % of GNI) in Minerals in 1995 to that in 1996?
Your answer should be compact. 0.89. What is the ratio of the Cost (as % of GNI) of Energy in 1995 to that in 1996?
Your response must be concise. 0.57. What is the ratio of the Cost (as % of GNI) in Water in 1995 to that in 1996?
Provide a short and direct response. 1.02. What is the difference between the highest and the second highest Cost (as % of GNI) of Coal?
Offer a terse response. 0.03. What is the difference between the highest and the second highest Cost (as % of GNI) of Minerals?
Your answer should be very brief. 0.35. What is the difference between the highest and the second highest Cost (as % of GNI) of Energy?
Your response must be concise. 0.07. What is the difference between the highest and the second highest Cost (as % of GNI) in Water?
Provide a short and direct response. 0.26. What is the difference between the highest and the lowest Cost (as % of GNI) of Coal?
Your answer should be very brief. 0.32. What is the difference between the highest and the lowest Cost (as % of GNI) of Energy?
Offer a terse response. 0.44. What is the difference between the highest and the lowest Cost (as % of GNI) in Water?
Your answer should be compact. 8.07. 